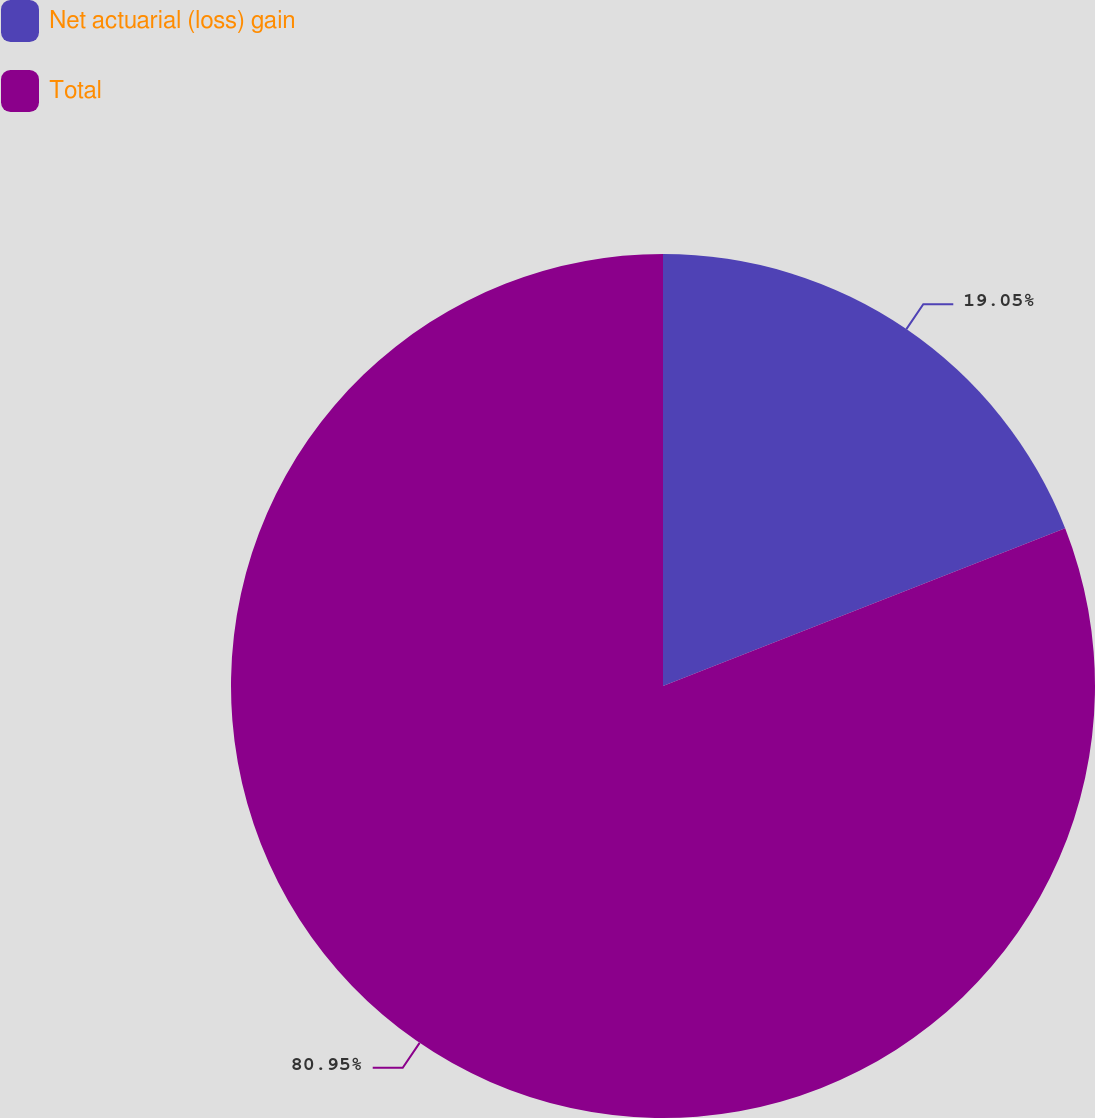Convert chart to OTSL. <chart><loc_0><loc_0><loc_500><loc_500><pie_chart><fcel>Net actuarial (loss) gain<fcel>Total<nl><fcel>19.05%<fcel>80.95%<nl></chart> 